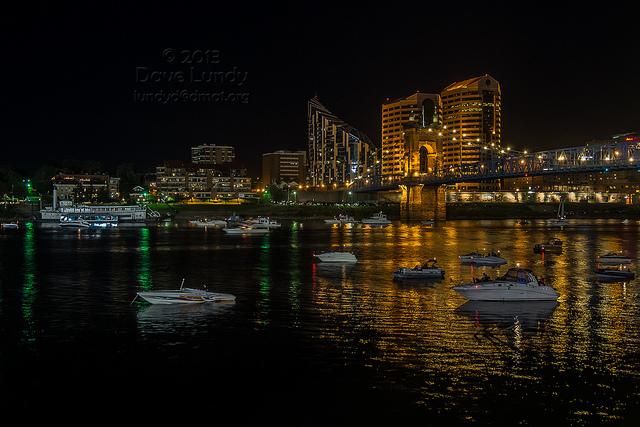Is this a romantic setting for a date?
Be succinct. Yes. Does this appear to be in a large city?
Give a very brief answer. Yes. What is the color of the water?
Quick response, please. Black. Who took this photo?
Be succinct. Human. Is this daytime?
Give a very brief answer. No. Is this dry land?
Write a very short answer. No. If you were here, would you know what time it is?
Keep it brief. Yes. How many boats are in the harbor?
Quick response, please. 14. What color is this roof?
Short answer required. Yellow. 